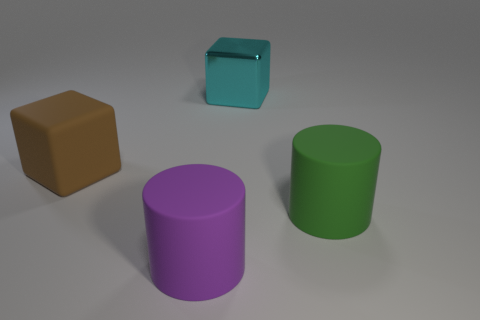Add 4 brown matte blocks. How many objects exist? 8 Add 1 cyan objects. How many cyan objects are left? 2 Add 2 rubber cylinders. How many rubber cylinders exist? 4 Subtract 0 red cylinders. How many objects are left? 4 Subtract all brown things. Subtract all cyan blocks. How many objects are left? 2 